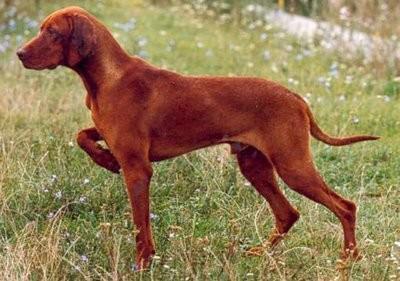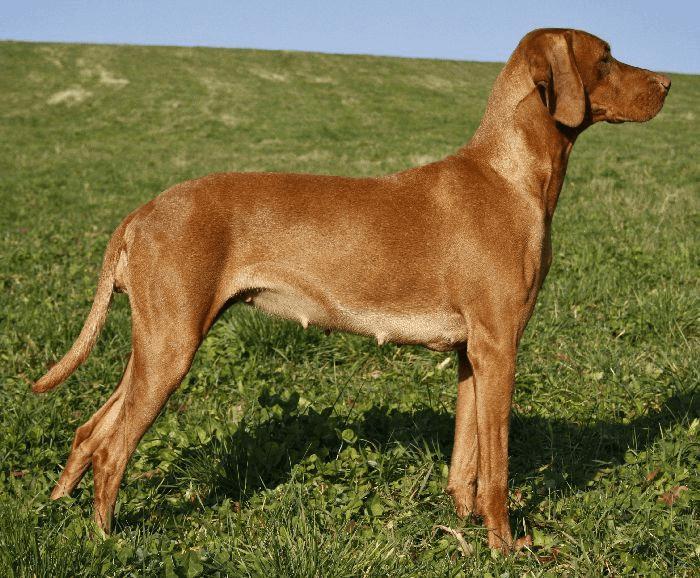The first image is the image on the left, the second image is the image on the right. Considering the images on both sides, is "One of the images shows a brown dog with one of its front legs raised and the other image shows a brown dog standing in grass." valid? Answer yes or no. Yes. The first image is the image on the left, the second image is the image on the right. Considering the images on both sides, is "One dog has it's front leg up and bent in a pose." valid? Answer yes or no. Yes. 